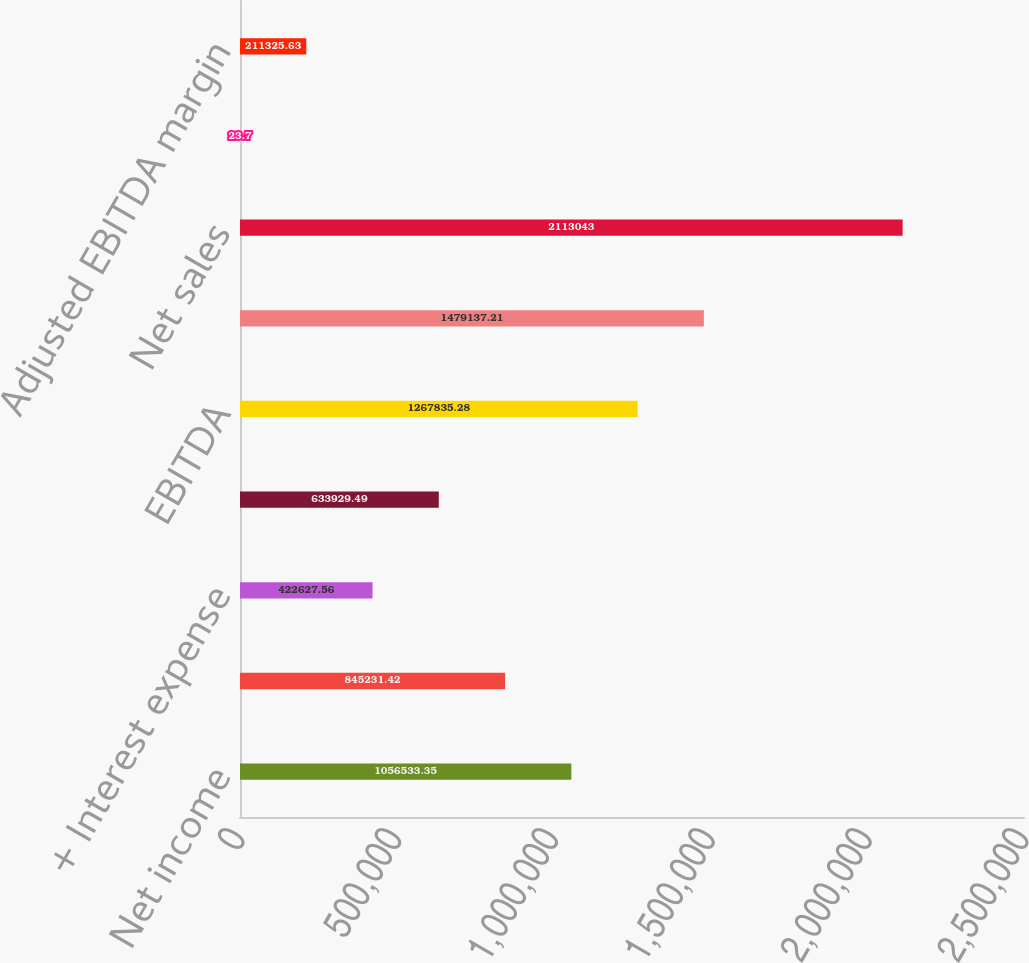Convert chart. <chart><loc_0><loc_0><loc_500><loc_500><bar_chart><fcel>Net income<fcel>+ Provision for income taxes<fcel>+ Interest expense<fcel>+ Depreciation and<fcel>EBITDA<fcel>Adjusted EBITDA<fcel>Net sales<fcel>EBITDA margin<fcel>Adjusted EBITDA margin<nl><fcel>1.05653e+06<fcel>845231<fcel>422628<fcel>633929<fcel>1.26784e+06<fcel>1.47914e+06<fcel>2.11304e+06<fcel>23.7<fcel>211326<nl></chart> 